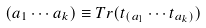<formula> <loc_0><loc_0><loc_500><loc_500>( a _ { 1 } \cdots a _ { k } ) \equiv T r ( t _ { ( a _ { 1 } } \cdots t _ { a _ { k } ) } )</formula> 